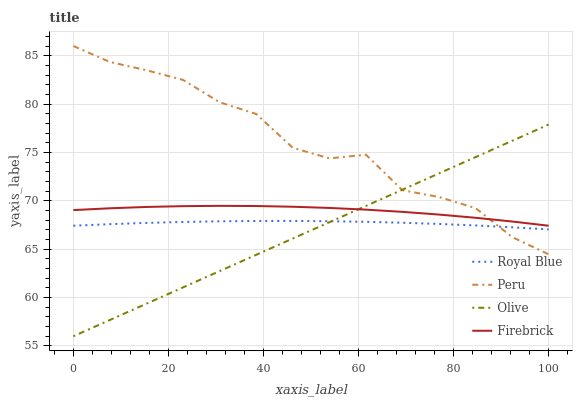Does Olive have the minimum area under the curve?
Answer yes or no. Yes. Does Peru have the maximum area under the curve?
Answer yes or no. Yes. Does Royal Blue have the minimum area under the curve?
Answer yes or no. No. Does Royal Blue have the maximum area under the curve?
Answer yes or no. No. Is Olive the smoothest?
Answer yes or no. Yes. Is Peru the roughest?
Answer yes or no. Yes. Is Royal Blue the smoothest?
Answer yes or no. No. Is Royal Blue the roughest?
Answer yes or no. No. Does Royal Blue have the lowest value?
Answer yes or no. No. Does Firebrick have the highest value?
Answer yes or no. No. Is Royal Blue less than Firebrick?
Answer yes or no. Yes. Is Firebrick greater than Royal Blue?
Answer yes or no. Yes. Does Royal Blue intersect Firebrick?
Answer yes or no. No. 